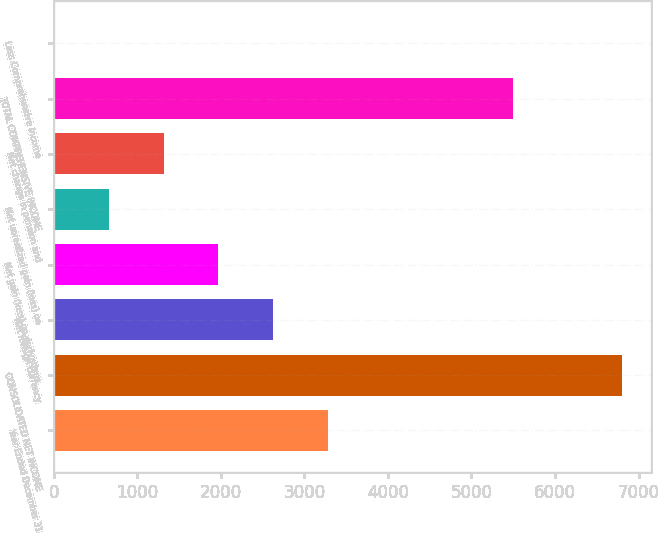Convert chart. <chart><loc_0><loc_0><loc_500><loc_500><bar_chart><fcel>Year Ended December 31<fcel>CONSOLIDATED NET INCOME<fcel>Net foreign currency<fcel>Net gain (loss) on derivatives<fcel>Net unrealized gain (loss) on<fcel>Net change in pension and<fcel>TOTAL COMPREHENSIVE INCOME<fcel>Less Comprehensive income<nl><fcel>3280<fcel>6804<fcel>2626<fcel>1972<fcel>664<fcel>1318<fcel>5496<fcel>10<nl></chart> 